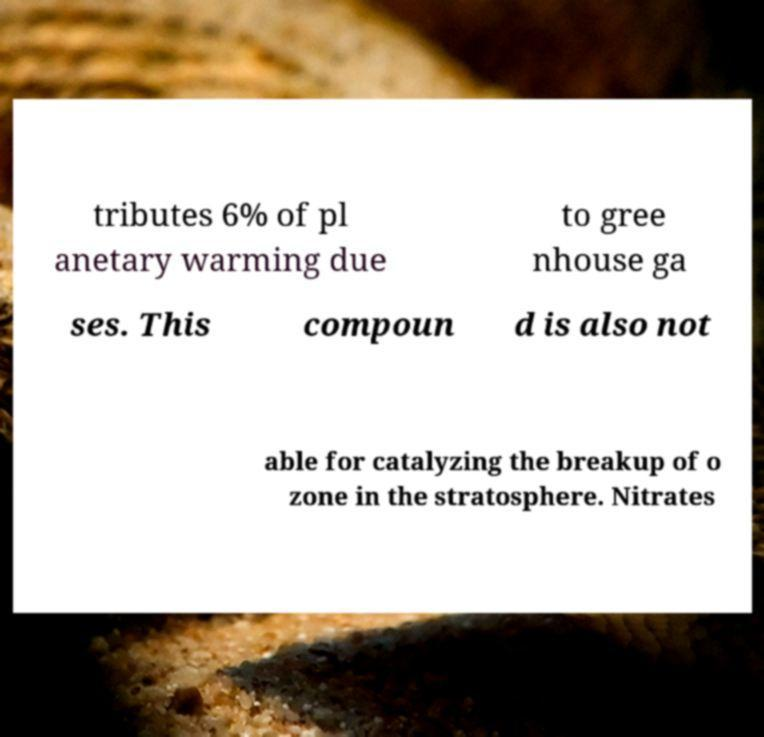What messages or text are displayed in this image? I need them in a readable, typed format. tributes 6% of pl anetary warming due to gree nhouse ga ses. This compoun d is also not able for catalyzing the breakup of o zone in the stratosphere. Nitrates 